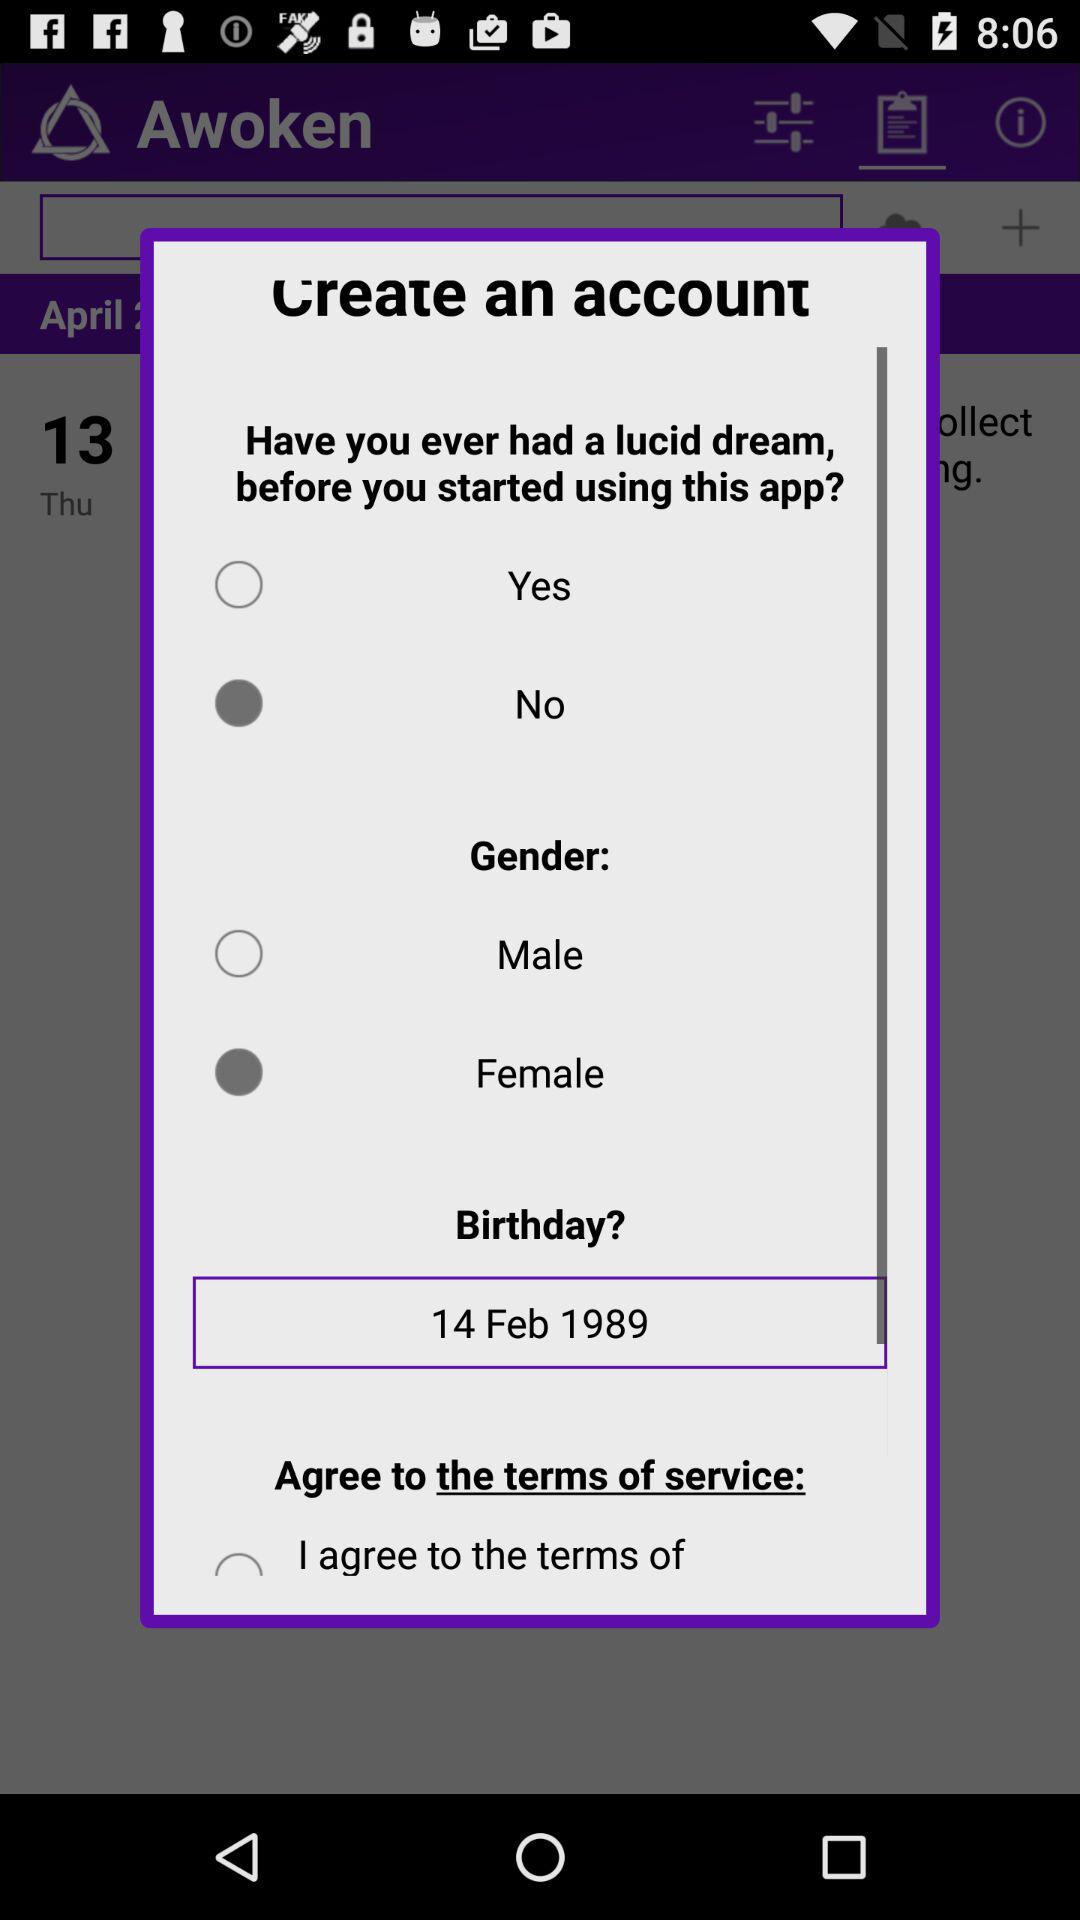What is the selected gender? The selected gender is female. 